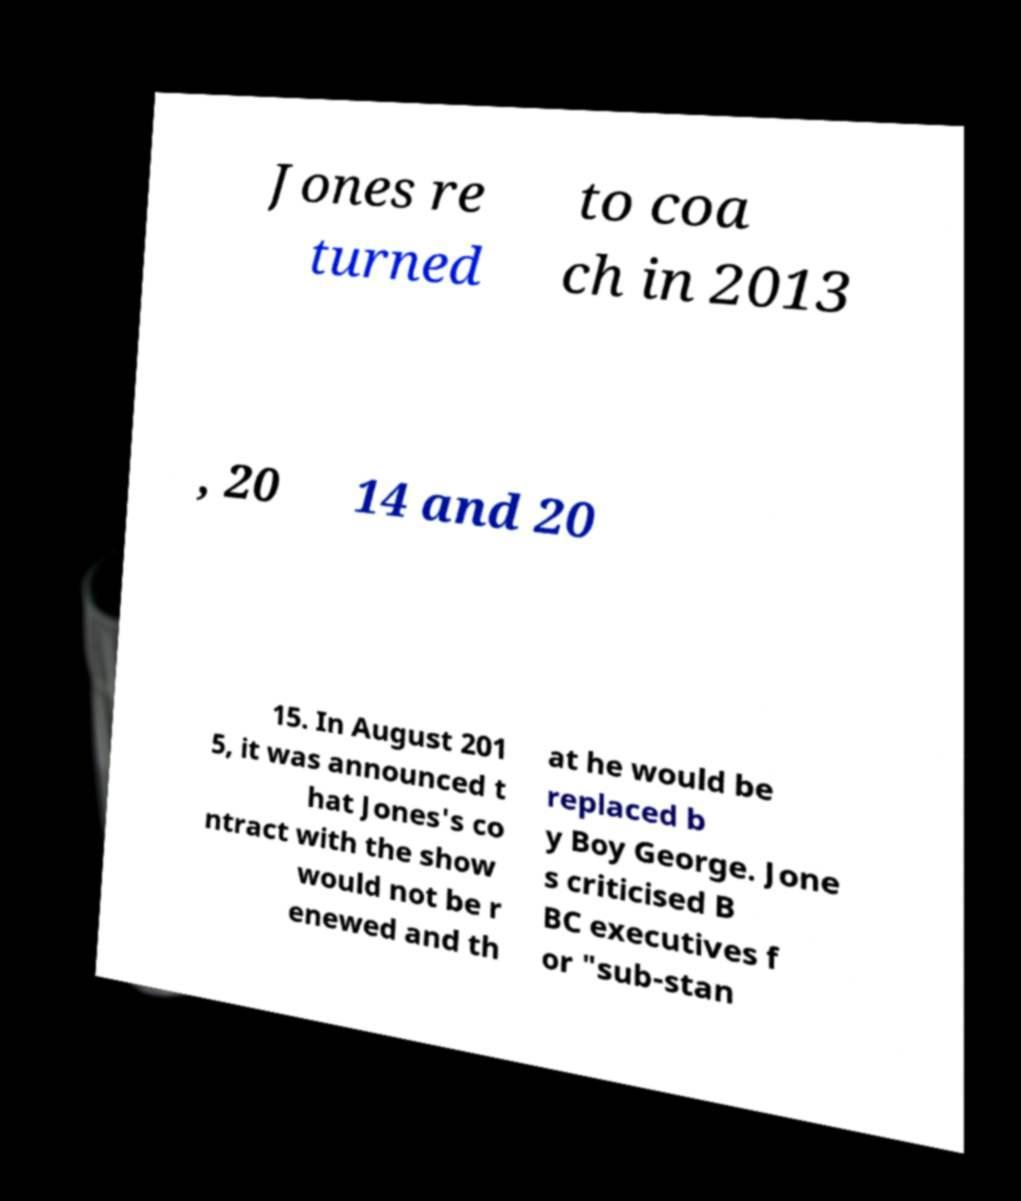There's text embedded in this image that I need extracted. Can you transcribe it verbatim? Jones re turned to coa ch in 2013 , 20 14 and 20 15. In August 201 5, it was announced t hat Jones's co ntract with the show would not be r enewed and th at he would be replaced b y Boy George. Jone s criticised B BC executives f or "sub-stan 